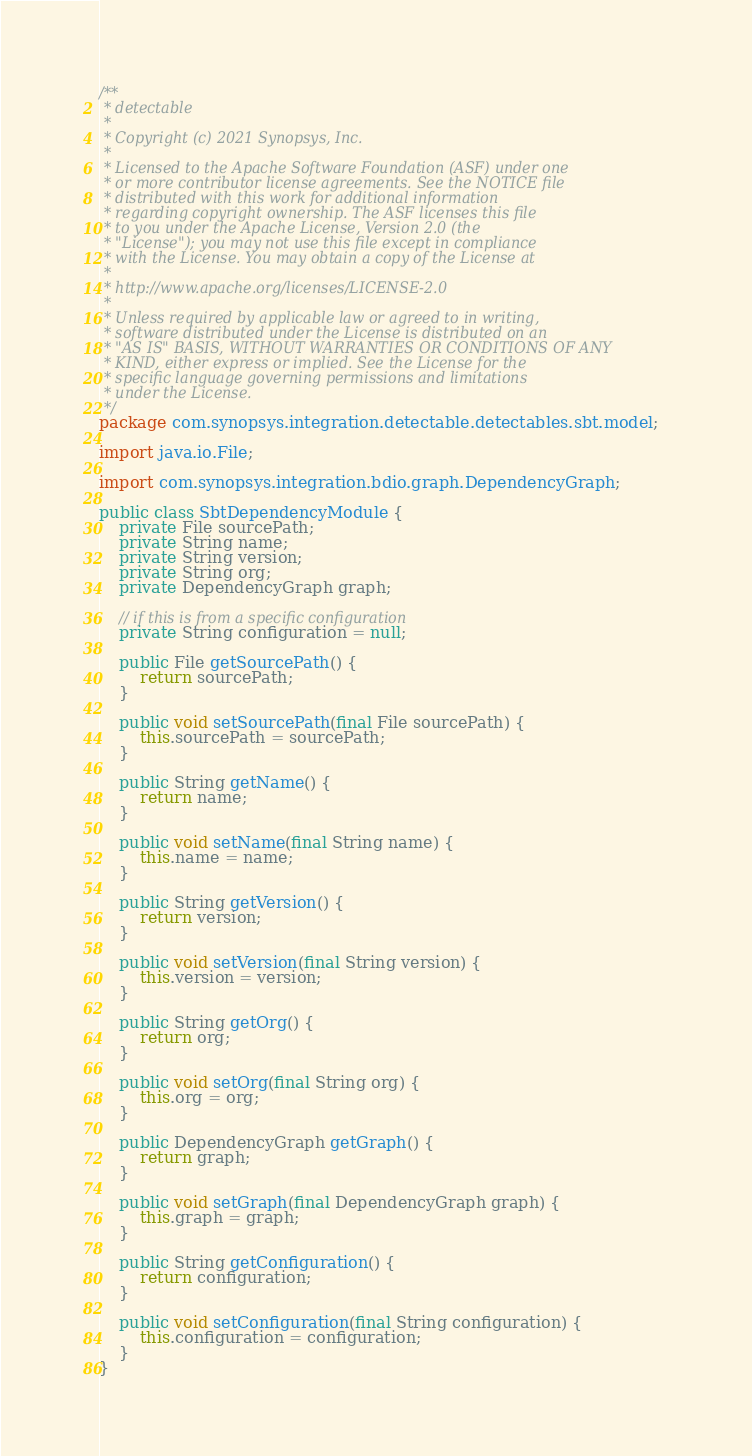<code> <loc_0><loc_0><loc_500><loc_500><_Java_>/**
 * detectable
 *
 * Copyright (c) 2021 Synopsys, Inc.
 *
 * Licensed to the Apache Software Foundation (ASF) under one
 * or more contributor license agreements. See the NOTICE file
 * distributed with this work for additional information
 * regarding copyright ownership. The ASF licenses this file
 * to you under the Apache License, Version 2.0 (the
 * "License"); you may not use this file except in compliance
 * with the License. You may obtain a copy of the License at
 *
 * http://www.apache.org/licenses/LICENSE-2.0
 *
 * Unless required by applicable law or agreed to in writing,
 * software distributed under the License is distributed on an
 * "AS IS" BASIS, WITHOUT WARRANTIES OR CONDITIONS OF ANY
 * KIND, either express or implied. See the License for the
 * specific language governing permissions and limitations
 * under the License.
 */
package com.synopsys.integration.detectable.detectables.sbt.model;

import java.io.File;

import com.synopsys.integration.bdio.graph.DependencyGraph;

public class SbtDependencyModule {
    private File sourcePath;
    private String name;
    private String version;
    private String org;
    private DependencyGraph graph;

    // if this is from a specific configuration
    private String configuration = null;

    public File getSourcePath() {
        return sourcePath;
    }

    public void setSourcePath(final File sourcePath) {
        this.sourcePath = sourcePath;
    }

    public String getName() {
        return name;
    }

    public void setName(final String name) {
        this.name = name;
    }

    public String getVersion() {
        return version;
    }

    public void setVersion(final String version) {
        this.version = version;
    }

    public String getOrg() {
        return org;
    }

    public void setOrg(final String org) {
        this.org = org;
    }

    public DependencyGraph getGraph() {
        return graph;
    }

    public void setGraph(final DependencyGraph graph) {
        this.graph = graph;
    }

    public String getConfiguration() {
        return configuration;
    }

    public void setConfiguration(final String configuration) {
        this.configuration = configuration;
    }
}
</code> 